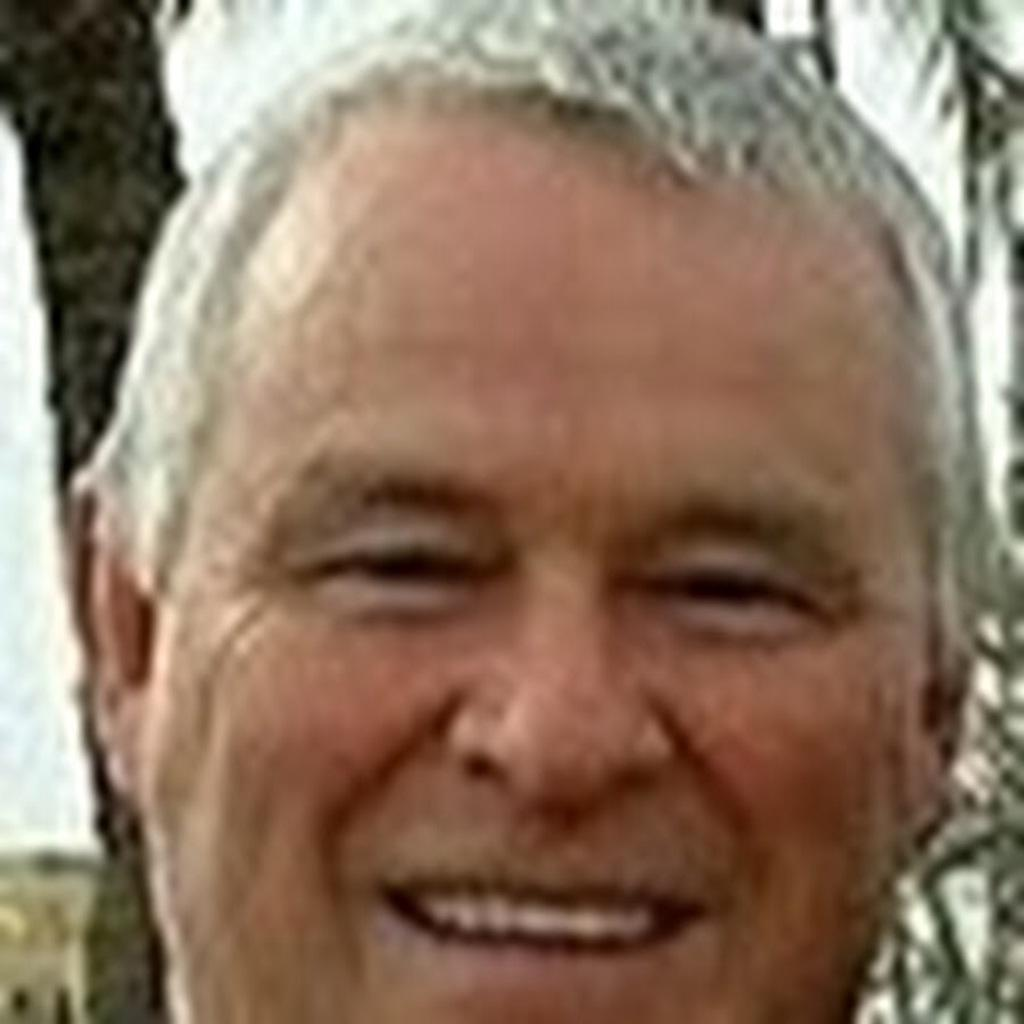What is the main subject of the image? There is a man's face in the image. What can be seen in the background of the image? The sky is visible in the background of the image. What is the tendency of the foot in the image? There is no foot present in the image; it only features a man's face and the sky in the background. 